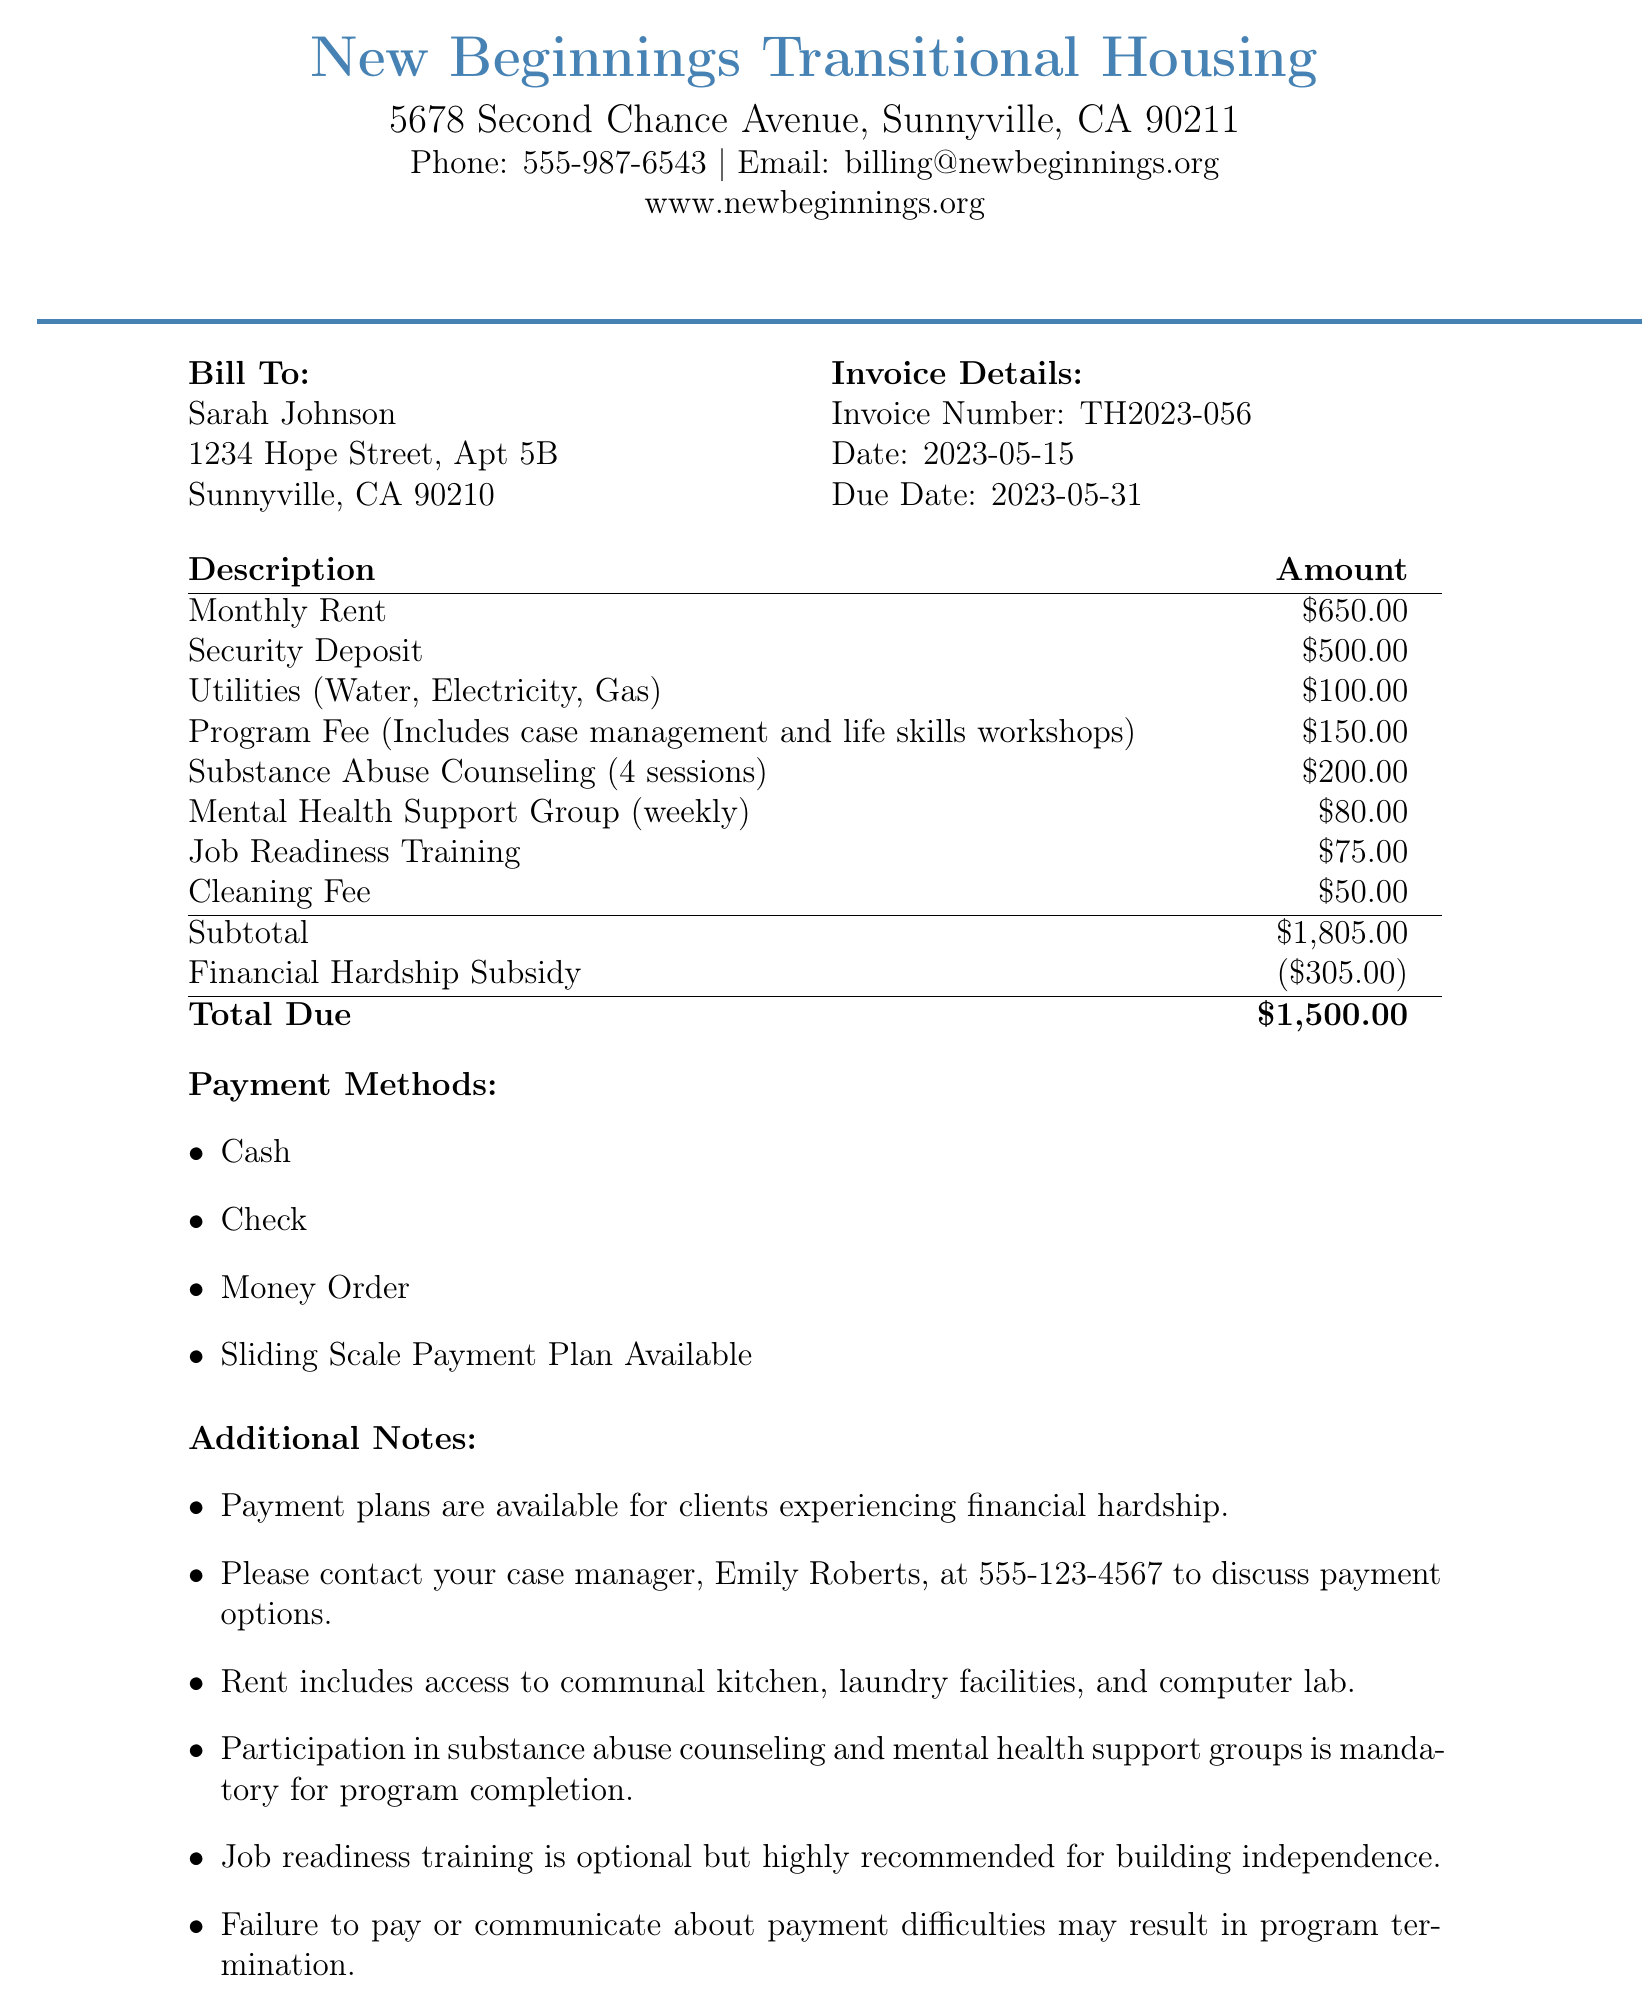What is the invoice number? The invoice number is specified in the document under "Invoice Details."
Answer: TH2023-056 What is the total due amount? The total due amount is provided at the bottom of the itemized fees section.
Answer: $1,500.00 Who is the client? The client's name is listed in the "Bill To" section of the invoice.
Answer: Sarah Johnson When is the due date for payment? The due date is mentioned under "Invoice Details."
Answer: 2023-05-31 What is the amount for the Security Deposit? The amount for the Security Deposit is included in the itemized fees.
Answer: $500.00 What discount is applied to the invoice? The discount applicable is noted just before the total due amount.
Answer: Financial Hardship Subsidy Is job readiness training mandatory? This information is mentioned in the Additional Notes section of the document.
Answer: No How many sessions of substance abuse counseling are included? The number of sessions is noted in the description of the substance abuse counseling item.
Answer: 4 sessions What are the payment methods available? The payment methods are listed in their own section in the document.
Answer: Cash, Check, Money Order, Sliding Scale Payment Plan Available What is included in the rent? The inclusions of the rent are stated in the Additional Notes section.
Answer: Access to communal kitchen, laundry facilities, and computer lab 